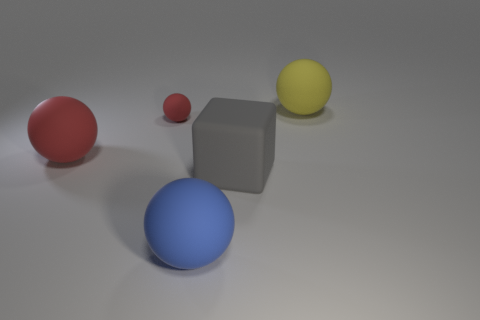Is there any other thing of the same color as the cube?
Provide a short and direct response. No. There is a large yellow thing that is the same shape as the blue rubber thing; what material is it?
Offer a very short reply. Rubber. There is a ball that is right of the large matte thing in front of the large cube; what color is it?
Offer a terse response. Yellow. There is a red object that is made of the same material as the tiny red ball; what size is it?
Offer a terse response. Large. How many small things have the same shape as the big red rubber object?
Provide a short and direct response. 1. What number of things are big rubber balls that are behind the blue matte thing or large things behind the big gray cube?
Your answer should be very brief. 2. How many yellow matte balls are in front of the matte sphere that is in front of the big block?
Offer a terse response. 0. Do the large rubber object in front of the large gray rubber object and the matte thing to the right of the big gray rubber object have the same shape?
Ensure brevity in your answer.  Yes. What is the shape of the big rubber object that is the same color as the small ball?
Keep it short and to the point. Sphere. Are there any large blue balls that have the same material as the small thing?
Make the answer very short. Yes. 